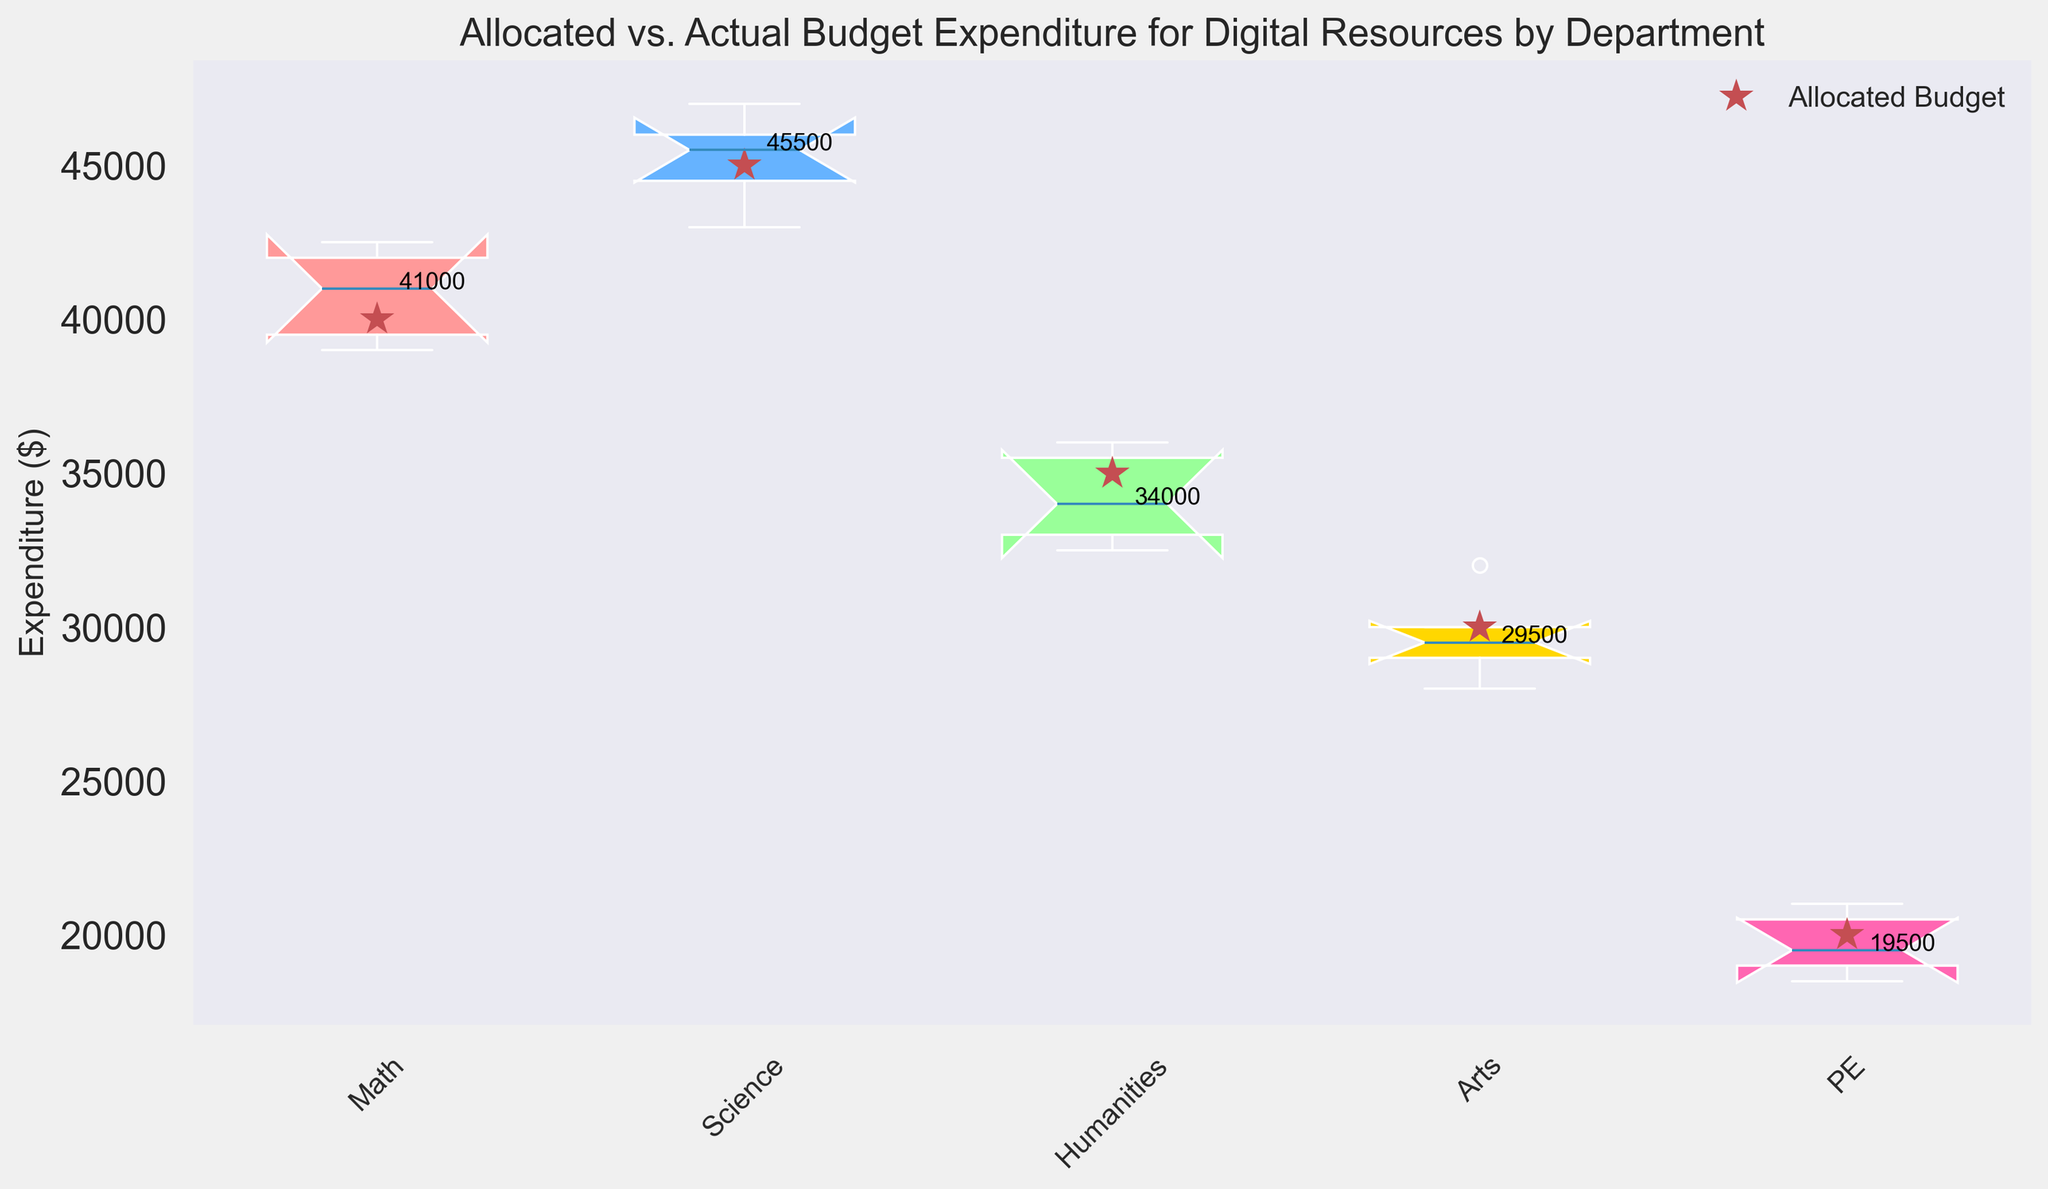Which department has the highest median actual expenditure? By observing the medians marked on the box plots, we can compare the median values across departments. The department with the highest median actual expenditure is the Science department.
Answer: Science Is the allocated budget ever lower than the median actual expenditure in any department? By comparing the red star markers (allocated budget) and the median lines of the box plots, we see that the allocated budget for the Math and Science departments is lower than their median actual expenditures.
Answer: Yes How does the range of actual expenditures in the Humanities department compare to that in the Arts department? To compare the ranges, observe the lengths of the box plots for Humanities and Arts. The box plot for Humanities has a wider range (gap between the lowest and highest data points) compared to Arts, indicating more variability in actual expenditures in the Humanities department.
Answer: Humanities has a wider range Which department has actual expenditures that are most consistent with its allocated budget? The department where the actual expenditures (box plot) are closest to the allocated budget (red star) is where consistency is highest. For PE, the red star is closer to the box plot data points, indicating more consistent actual expenditures relative to the allocated budget.
Answer: PE Are any departments overspending on their digital resources based on the allocated budget? Overspending can be identified where the median line of the box plot is higher than the red star for the allocated budget. Both the Math and Science departments show median actual expenditures that are higher than their allocated budgets, indicating overspending.
Answer: Math and Science For which department is the discrepancy between the allocated budget and actual expenditures the largest? Calculate the discrepancy by finding the difference between the allocated budget (red star) and the median actual expenditure (middle line of the box plot) for each department. The Math department has the largest discrepancy where the median actual expenditure is significantly higher than the allocated budget.
Answer: Math How does the median actual expenditure in the Arts department compare to its allocated budget? Observe the median line in the Arts department's box plot and compare it to the position of the red star (allocated budget). The median actual expenditure for Arts is below its allocated budget.
Answer: Below What is the median actual expenditure for the PE department? The median line in the PE department's box plot is marked with a data value. The median actual expenditure can be read directly from this line.
Answer: 19500 Which department has the lowest variation in actual expenditures? Variation can be assessed by the width of the interquartile range (IQR) in the box plot. The PE department has the shortest IQR, indicating the lowest variation in actual expenditures.
Answer: PE 